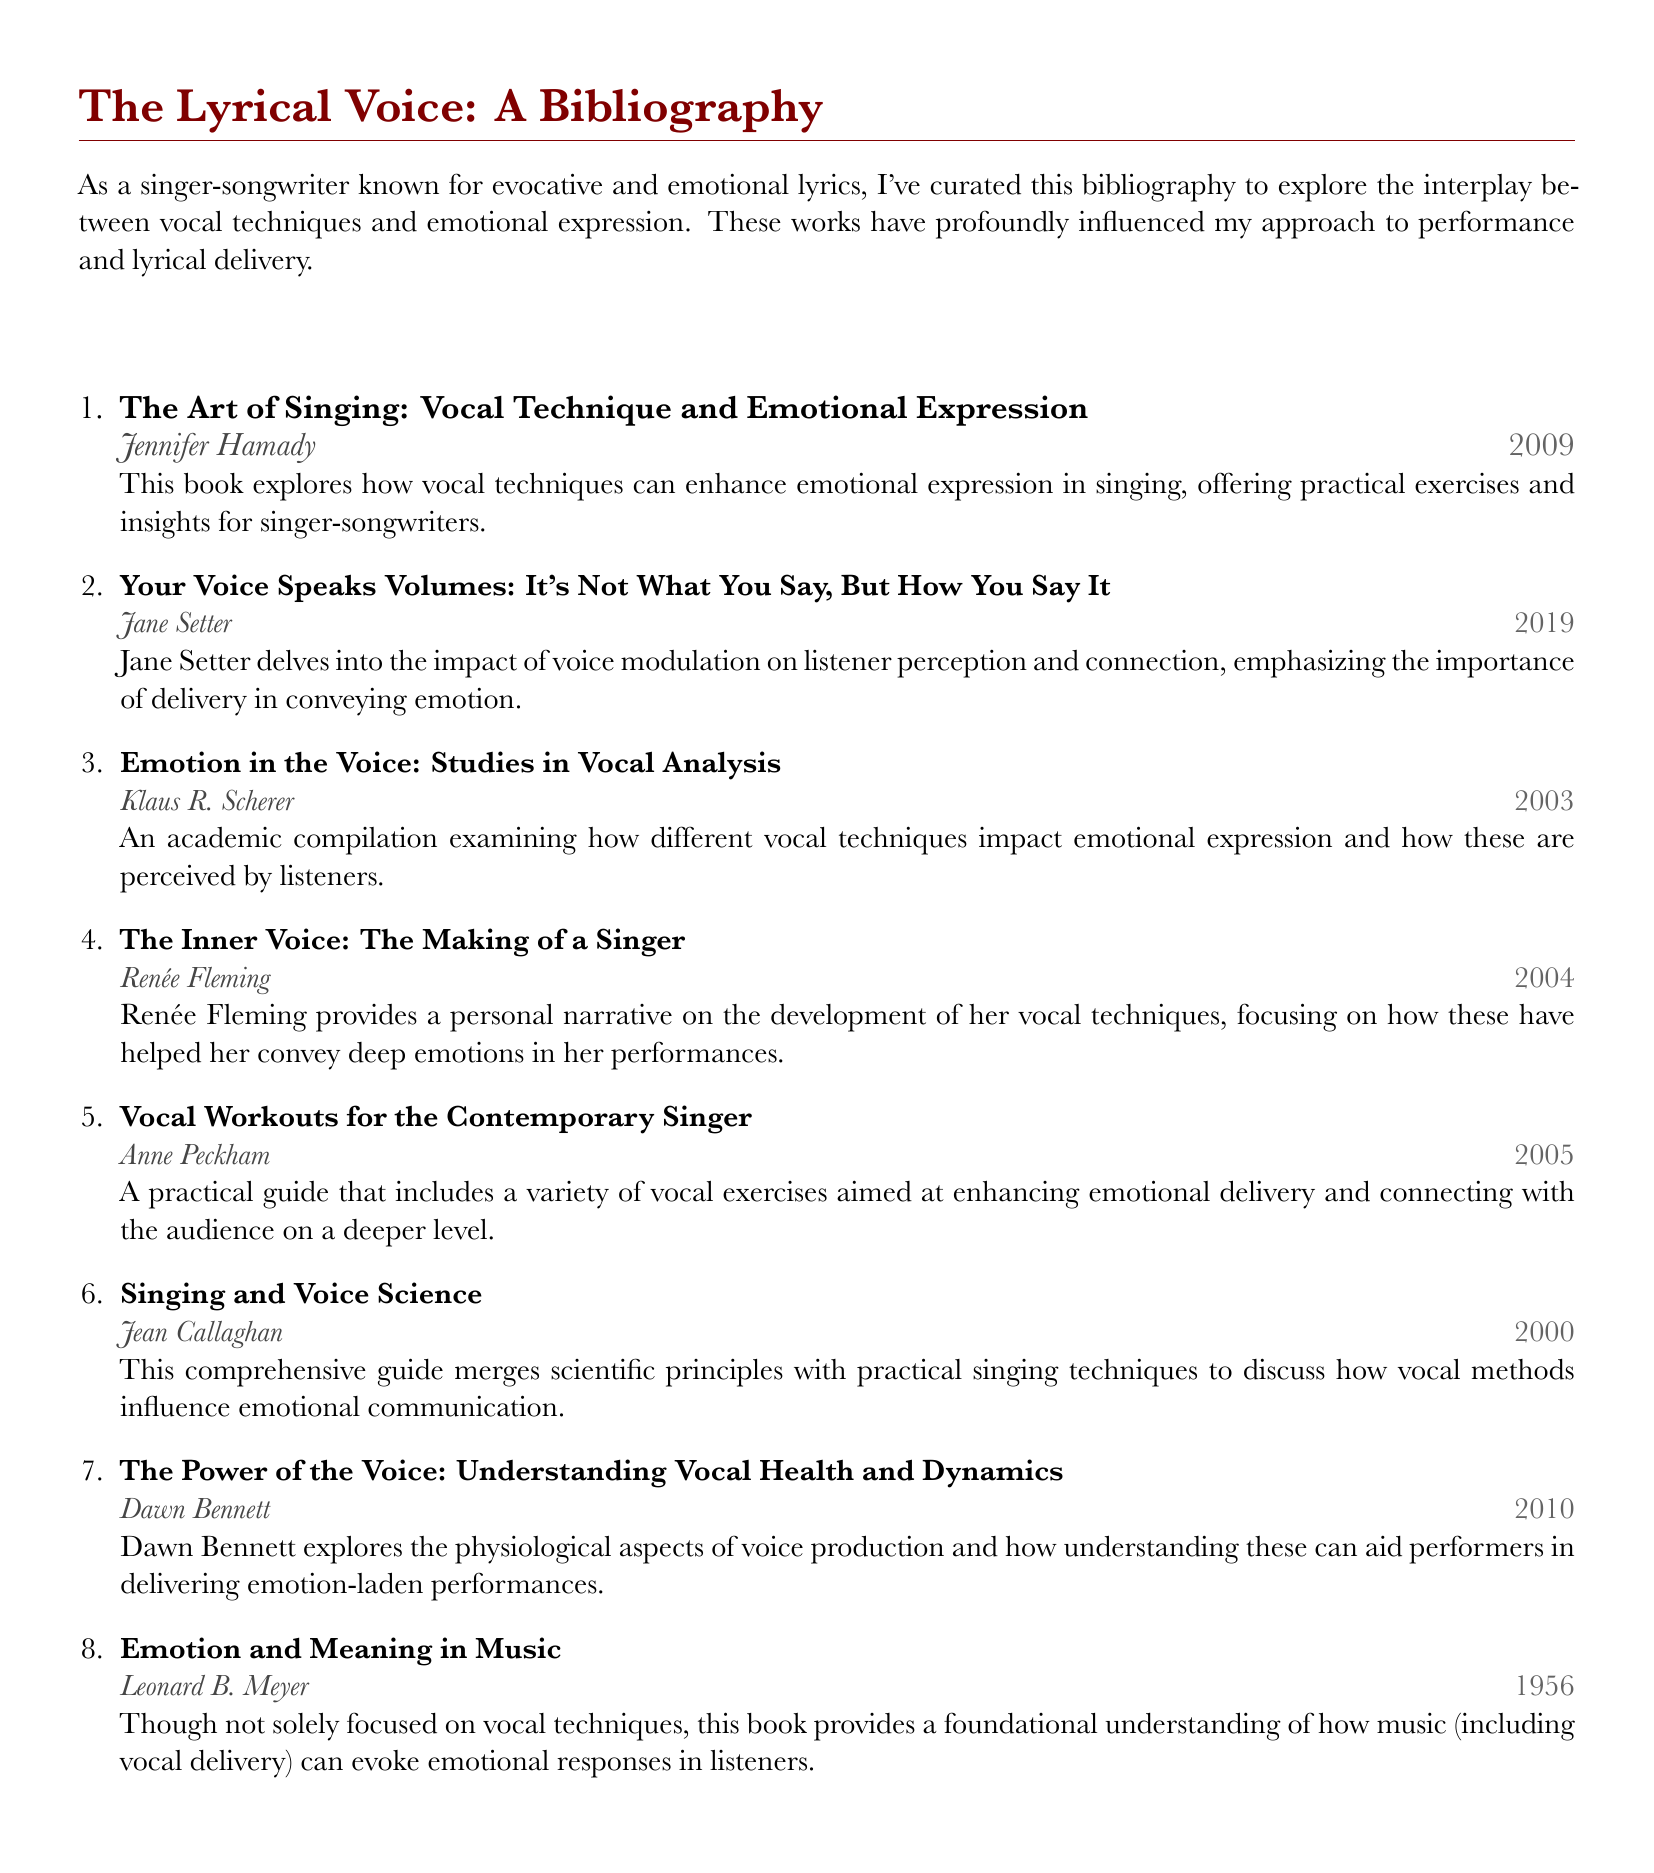What is the title of the bibliography? The title is prominently displayed at the top of the document, indicating the focus on vocal techniques and emotional expression.
Answer: The Lyrical Voice: A Bibliography Who is the author of the first entry? The first entry lists Jennifer Hamady as the author, providing an exploration of vocal techniques.
Answer: Jennifer Hamady In what year was "Your Voice Speaks Volumes" published? The year of publication is noted next to the author's name in the entry, indicating its release date.
Answer: 2019 How many entries are included in this bibliography? The number of entries can be counted from the list presented in the document.
Answer: Eight What is a key focus of the book "Emotion in the Voice"? The description of this book indicates its examination of vocal techniques and their effects on emotional expression.
Answer: Vocal techniques Who wrote "The Inner Voice: The Making of a Singer"? The document specifies Renée Fleming as the author of this personal narrative.
Answer: Renée Fleming Which book discusses the physiological aspects of voice production? The entry for this book focuses on how physiological understanding aids in emotional delivery.
Answer: The Power of the Voice: Understanding Vocal Health and Dynamics What type of guide is "Vocal Workouts for the Contemporary Singer"? The entry describes it as a practical guide that includes vocal exercises.
Answer: Practical guide 